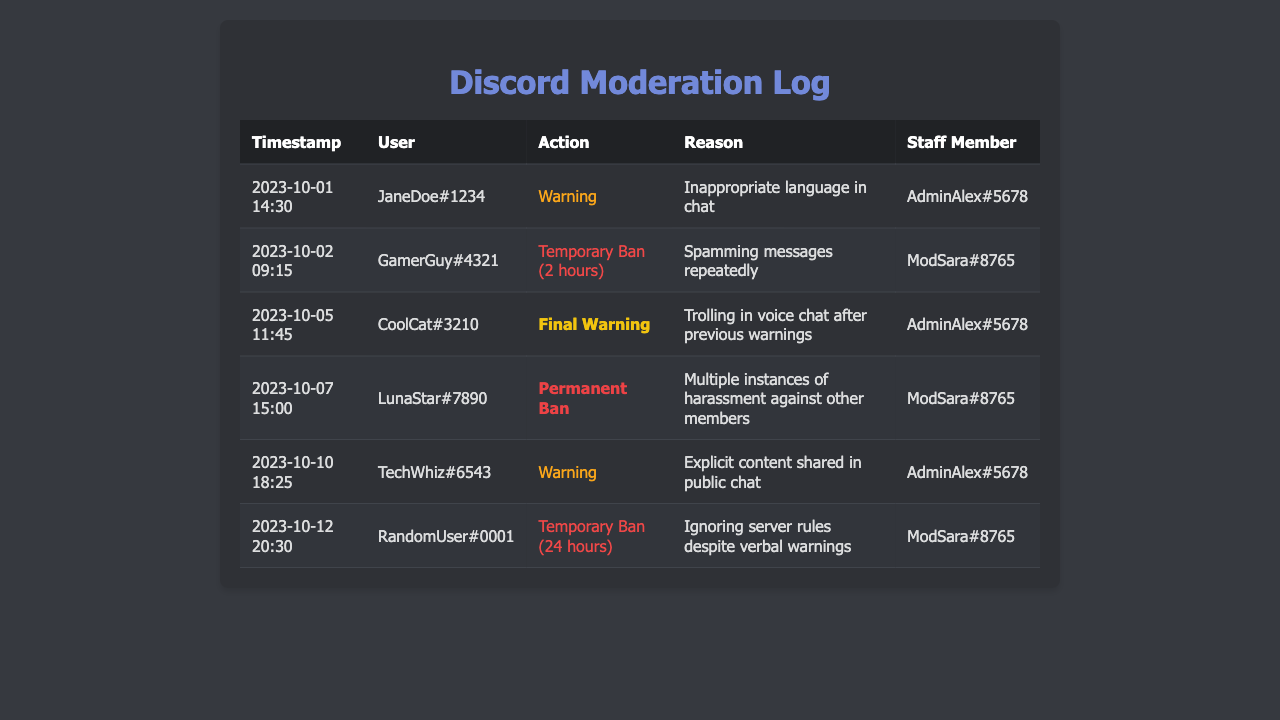what is the date of the final warning issued? The final warning was issued on October 5, 2023, which is recorded in the document.
Answer: October 5, 2023 who issued the warning to JaneDoe#1234? The document specifies that AdminAlex#5678 issued the warning to JaneDoe#1234.
Answer: AdminAlex#5678 how many temporary bans are listed? The document lists two instances of temporary bans, shown in the actions taken against GamerGuy#4321 and RandomUser#0001.
Answer: 2 what action was taken against LunaStar#7890? The document states that LunaStar#7890 received a permanent ban from the server.
Answer: Permanent Ban what was the reason for issuing a warning to TechWhiz#6543? The warning issued to TechWhiz#6543 was due to sharing explicit content in public chat.
Answer: Explicit content shared in public chat 